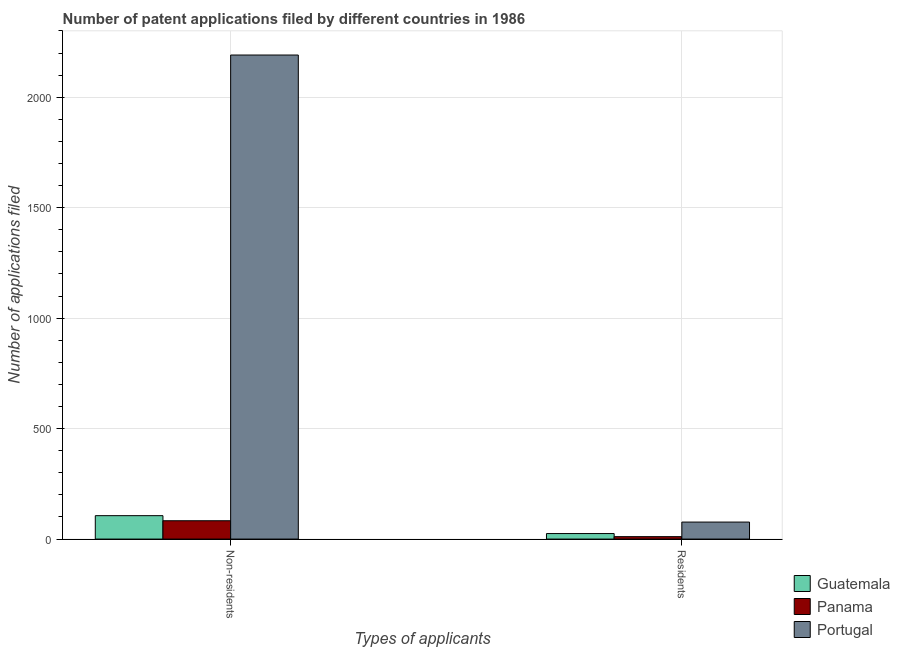How many different coloured bars are there?
Provide a short and direct response. 3. Are the number of bars per tick equal to the number of legend labels?
Your response must be concise. Yes. How many bars are there on the 2nd tick from the left?
Ensure brevity in your answer.  3. What is the label of the 1st group of bars from the left?
Keep it short and to the point. Non-residents. What is the number of patent applications by non residents in Guatemala?
Ensure brevity in your answer.  106. Across all countries, what is the maximum number of patent applications by non residents?
Give a very brief answer. 2191. Across all countries, what is the minimum number of patent applications by non residents?
Your answer should be compact. 83. In which country was the number of patent applications by non residents maximum?
Your answer should be compact. Portugal. In which country was the number of patent applications by non residents minimum?
Your response must be concise. Panama. What is the total number of patent applications by residents in the graph?
Make the answer very short. 113. What is the difference between the number of patent applications by non residents in Panama and that in Guatemala?
Provide a succinct answer. -23. What is the difference between the number of patent applications by residents in Panama and the number of patent applications by non residents in Portugal?
Provide a succinct answer. -2180. What is the average number of patent applications by non residents per country?
Your response must be concise. 793.33. What is the difference between the number of patent applications by non residents and number of patent applications by residents in Portugal?
Ensure brevity in your answer.  2114. What is the ratio of the number of patent applications by residents in Portugal to that in Guatemala?
Your response must be concise. 3.08. Is the number of patent applications by residents in Guatemala less than that in Panama?
Offer a very short reply. No. In how many countries, is the number of patent applications by non residents greater than the average number of patent applications by non residents taken over all countries?
Provide a succinct answer. 1. What does the 2nd bar from the left in Non-residents represents?
Your answer should be compact. Panama. What does the 2nd bar from the right in Non-residents represents?
Your answer should be very brief. Panama. How many bars are there?
Provide a short and direct response. 6. What is the difference between two consecutive major ticks on the Y-axis?
Your response must be concise. 500. Are the values on the major ticks of Y-axis written in scientific E-notation?
Your response must be concise. No. Does the graph contain grids?
Your response must be concise. Yes. How many legend labels are there?
Your answer should be very brief. 3. How are the legend labels stacked?
Ensure brevity in your answer.  Vertical. What is the title of the graph?
Provide a succinct answer. Number of patent applications filed by different countries in 1986. What is the label or title of the X-axis?
Give a very brief answer. Types of applicants. What is the label or title of the Y-axis?
Offer a terse response. Number of applications filed. What is the Number of applications filed in Guatemala in Non-residents?
Your answer should be compact. 106. What is the Number of applications filed of Panama in Non-residents?
Provide a succinct answer. 83. What is the Number of applications filed of Portugal in Non-residents?
Keep it short and to the point. 2191. What is the Number of applications filed in Panama in Residents?
Keep it short and to the point. 11. What is the Number of applications filed in Portugal in Residents?
Offer a very short reply. 77. Across all Types of applicants, what is the maximum Number of applications filed of Guatemala?
Provide a short and direct response. 106. Across all Types of applicants, what is the maximum Number of applications filed of Panama?
Your response must be concise. 83. Across all Types of applicants, what is the maximum Number of applications filed in Portugal?
Provide a short and direct response. 2191. Across all Types of applicants, what is the minimum Number of applications filed in Panama?
Your answer should be compact. 11. What is the total Number of applications filed of Guatemala in the graph?
Ensure brevity in your answer.  131. What is the total Number of applications filed in Panama in the graph?
Provide a succinct answer. 94. What is the total Number of applications filed of Portugal in the graph?
Your answer should be compact. 2268. What is the difference between the Number of applications filed in Guatemala in Non-residents and that in Residents?
Your answer should be very brief. 81. What is the difference between the Number of applications filed in Portugal in Non-residents and that in Residents?
Provide a succinct answer. 2114. What is the difference between the Number of applications filed of Guatemala in Non-residents and the Number of applications filed of Panama in Residents?
Your response must be concise. 95. What is the difference between the Number of applications filed in Panama in Non-residents and the Number of applications filed in Portugal in Residents?
Make the answer very short. 6. What is the average Number of applications filed in Guatemala per Types of applicants?
Make the answer very short. 65.5. What is the average Number of applications filed in Portugal per Types of applicants?
Your response must be concise. 1134. What is the difference between the Number of applications filed of Guatemala and Number of applications filed of Panama in Non-residents?
Ensure brevity in your answer.  23. What is the difference between the Number of applications filed in Guatemala and Number of applications filed in Portugal in Non-residents?
Make the answer very short. -2085. What is the difference between the Number of applications filed of Panama and Number of applications filed of Portugal in Non-residents?
Give a very brief answer. -2108. What is the difference between the Number of applications filed in Guatemala and Number of applications filed in Portugal in Residents?
Give a very brief answer. -52. What is the difference between the Number of applications filed of Panama and Number of applications filed of Portugal in Residents?
Give a very brief answer. -66. What is the ratio of the Number of applications filed of Guatemala in Non-residents to that in Residents?
Offer a very short reply. 4.24. What is the ratio of the Number of applications filed in Panama in Non-residents to that in Residents?
Provide a short and direct response. 7.55. What is the ratio of the Number of applications filed of Portugal in Non-residents to that in Residents?
Provide a succinct answer. 28.45. What is the difference between the highest and the second highest Number of applications filed of Panama?
Provide a short and direct response. 72. What is the difference between the highest and the second highest Number of applications filed of Portugal?
Offer a very short reply. 2114. What is the difference between the highest and the lowest Number of applications filed of Guatemala?
Offer a terse response. 81. What is the difference between the highest and the lowest Number of applications filed in Portugal?
Ensure brevity in your answer.  2114. 